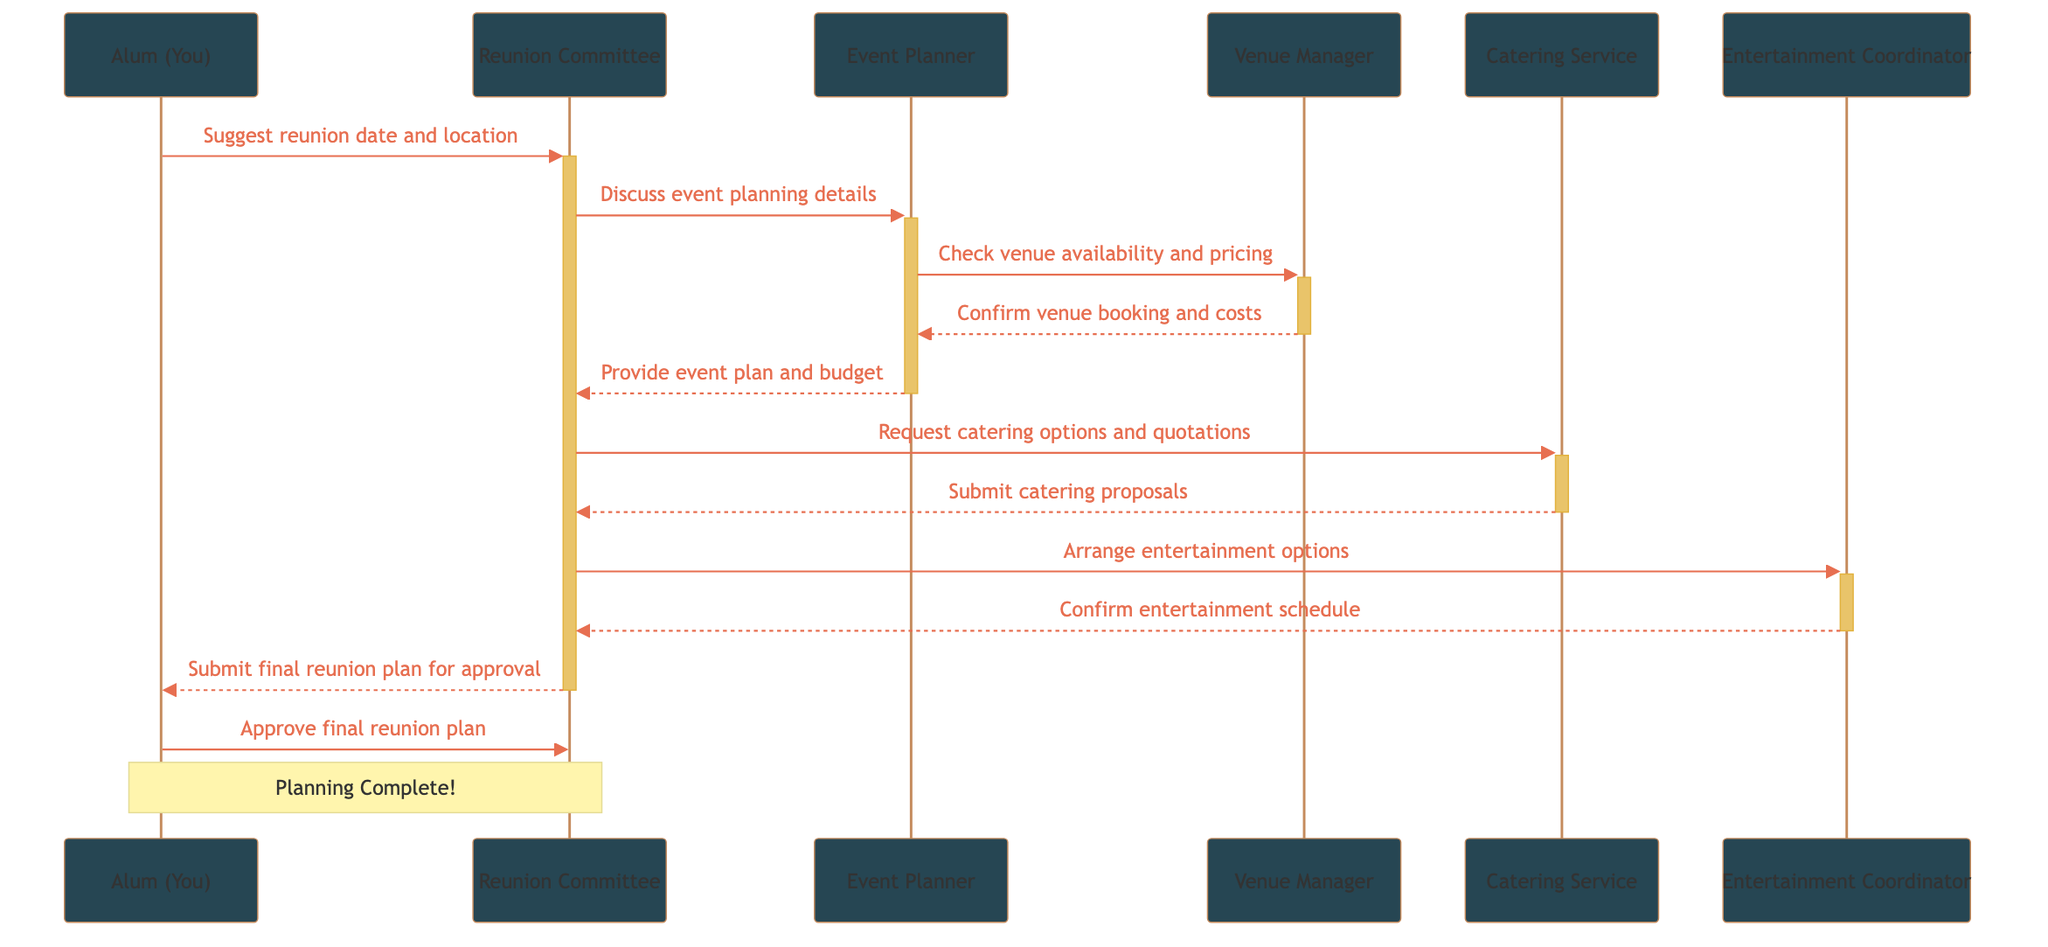What is the first message sent in the sequence? The first message is from "Alum (You)" to "Reunion Committee," suggesting a reunion date and location. It is the first interaction in the sequence diagram.
Answer: Suggest reunion date and location How many participants are involved in the reunion planning? There are 6 participants in total: Alum (You), Reunion Committee, Event Planner, Venue Manager, Catering Service, and Entertainment Coordinator.
Answer: 6 Who confirms the venue booking and costs? The Venue Manager is responsible for confirming the venue booking and costs after the Event Planner checks the availability and pricing.
Answer: Venue Manager What message does the Entertainment Coordinator send? The Entertainment Coordinator confirms the entertainment schedule to the Reunion Committee after they arranged entertainment options.
Answer: Confirm entertainment schedule At what point does the Alum (You) approve the final reunion plan? The Alum (You) approves the final reunion plan after the Reunion Committee submits it for approval, which is the last step before completing the planning.
Answer: Approve final reunion plan Which service is requested for catering options? The Reunion Committee requests catering options and quotations from the Catering Service after discussing event plans with the Event Planner.
Answer: Catering Service How many messages are sent from the Reunion Committee? The Reunion Committee sends 4 messages throughout the sequence, coordinating with the Event Planner, Catering Service, and Entertainment Coordinator, and submitting the final plan for approval.
Answer: 4 What is the main focus of the first interaction? The focus of the first interaction is the suggestion of the reunion date and location by the Alum (You) to the Reunion Committee.
Answer: Suggest reunion date and location What happens after the Event Planner receives venue confirmation? After the Event Planner receives venue confirmation from the Venue Manager, they provide the Reunion Committee with the event plan and budget.
Answer: Provide event plan and budget 